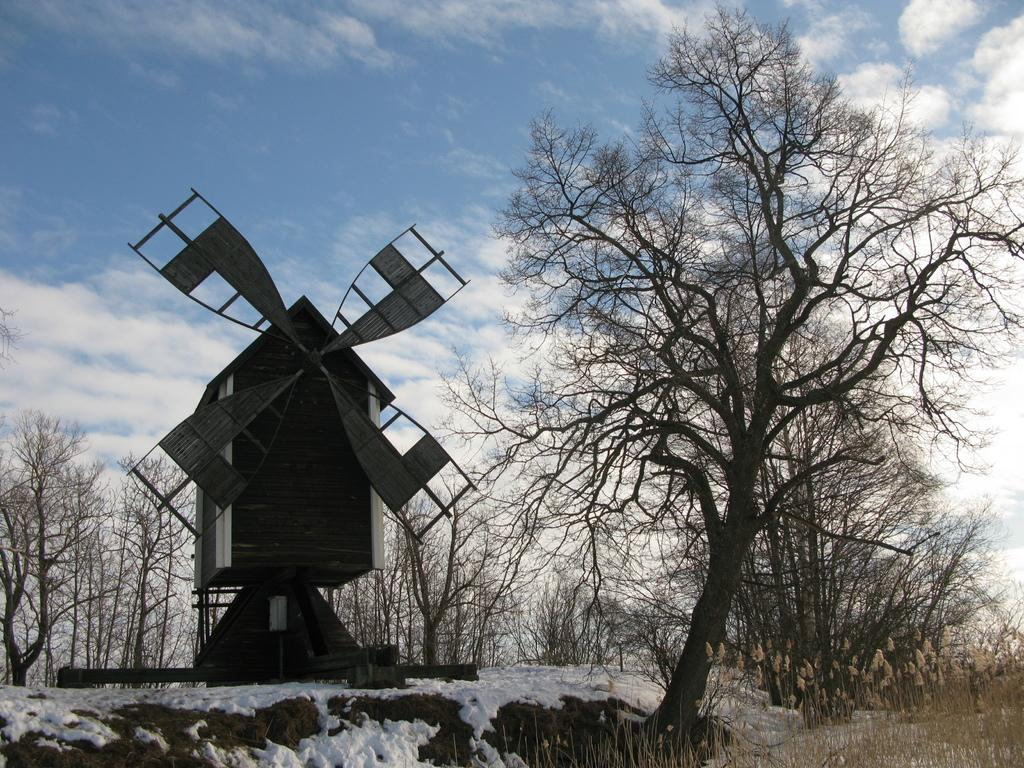What structure is located on the left side of the image? There is a windmill on the left side of the image. What type of vegetation can be seen in the image? There are trees and plants in the image. What is present at the bottom of the image? There is snow and plants at the bottom of the image. What is visible at the top of the image? The sky is visible at the top of the image. Can you tell me how many bears are sitting on the crib in the image? There are no bears or cribs present in the image. What type of ticket can be seen hanging from the windmill in the image? There is no ticket present in the image; it features a windmill, trees, snow, plants, and the sky. 